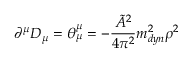Convert formula to latex. <formula><loc_0><loc_0><loc_500><loc_500>\partial ^ { \mu } D _ { \mu } = \theta _ { \mu } ^ { \mu } = - \frac { \tilde { A } ^ { 2 } } { 4 \pi ^ { 2 } } m _ { d y n } ^ { 2 } \rho ^ { 2 }</formula> 